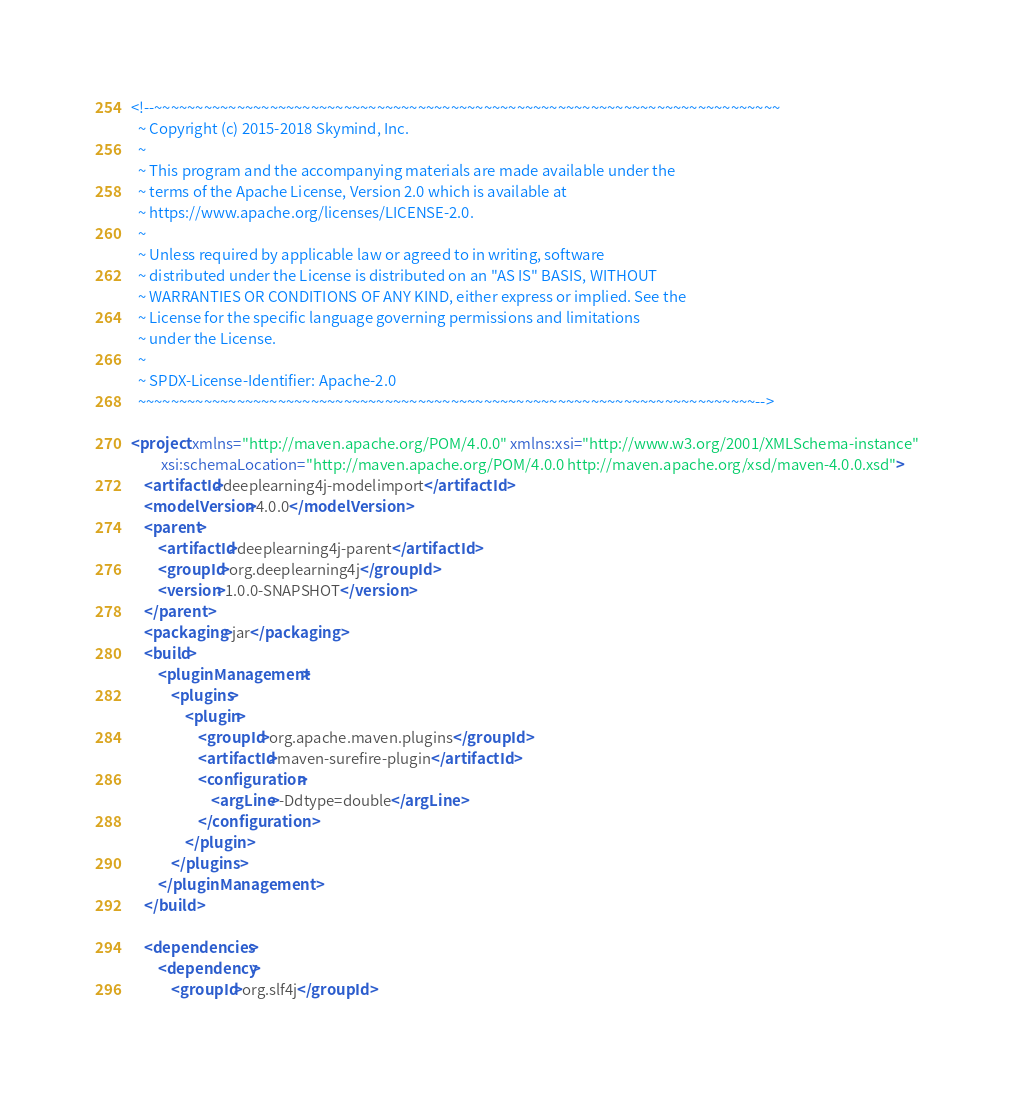<code> <loc_0><loc_0><loc_500><loc_500><_XML_><!--~~~~~~~~~~~~~~~~~~~~~~~~~~~~~~~~~~~~~~~~~~~~~~~~~~~~~~~~~~~~~~~~~~~~~~~~~~~~
  ~ Copyright (c) 2015-2018 Skymind, Inc.
  ~
  ~ This program and the accompanying materials are made available under the
  ~ terms of the Apache License, Version 2.0 which is available at
  ~ https://www.apache.org/licenses/LICENSE-2.0.
  ~
  ~ Unless required by applicable law or agreed to in writing, software
  ~ distributed under the License is distributed on an "AS IS" BASIS, WITHOUT
  ~ WARRANTIES OR CONDITIONS OF ANY KIND, either express or implied. See the
  ~ License for the specific language governing permissions and limitations
  ~ under the License.
  ~
  ~ SPDX-License-Identifier: Apache-2.0
  ~~~~~~~~~~~~~~~~~~~~~~~~~~~~~~~~~~~~~~~~~~~~~~~~~~~~~~~~~~~~~~~~~~~~~~~~~~~-->

<project xmlns="http://maven.apache.org/POM/4.0.0" xmlns:xsi="http://www.w3.org/2001/XMLSchema-instance"
         xsi:schemaLocation="http://maven.apache.org/POM/4.0.0 http://maven.apache.org/xsd/maven-4.0.0.xsd">
    <artifactId>deeplearning4j-modelimport</artifactId>
    <modelVersion>4.0.0</modelVersion>
    <parent>
        <artifactId>deeplearning4j-parent</artifactId>
        <groupId>org.deeplearning4j</groupId>
        <version>1.0.0-SNAPSHOT</version>
    </parent>
    <packaging>jar</packaging>
    <build>
        <pluginManagement>
            <plugins>
                <plugin>
                    <groupId>org.apache.maven.plugins</groupId>
                    <artifactId>maven-surefire-plugin</artifactId>
                    <configuration>
                        <argLine>-Ddtype=double</argLine>
                    </configuration>
                </plugin>
            </plugins>
        </pluginManagement>
    </build>

    <dependencies>
        <dependency>
            <groupId>org.slf4j</groupId></code> 